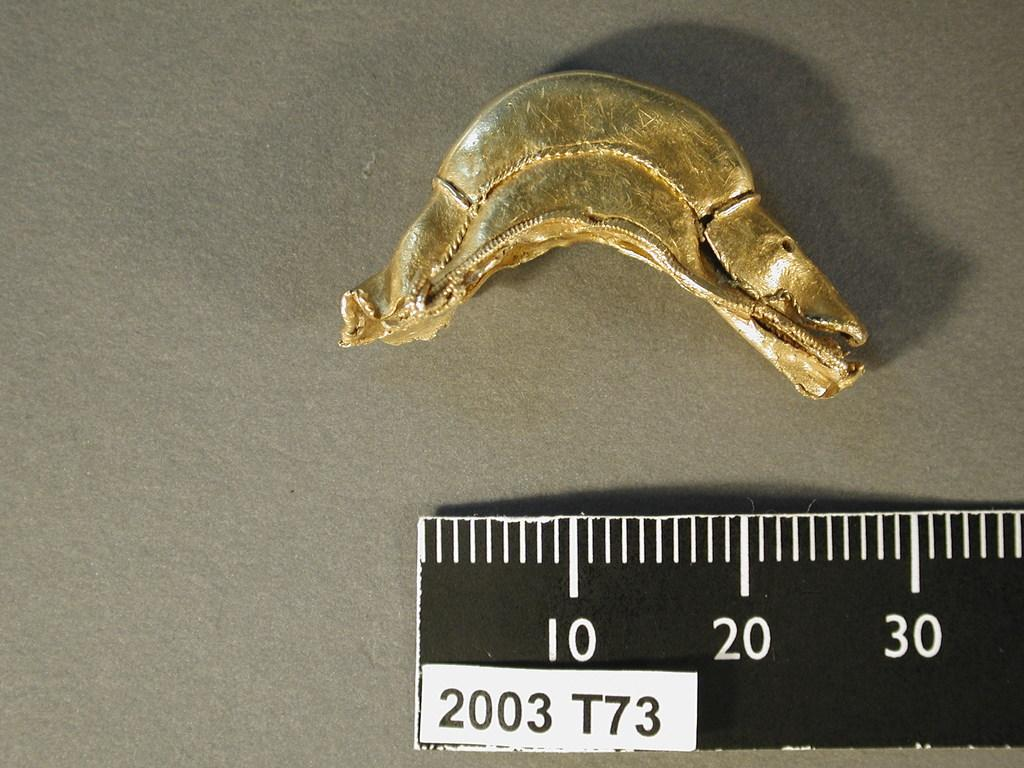Provide a one-sentence caption for the provided image. A curved, gold object being measured by a black ruler, showing a lenghe of approximately 30. 